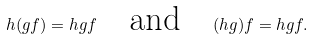<formula> <loc_0><loc_0><loc_500><loc_500>h ( g f ) = h g f \quad \text {and} \quad ( h g ) f = h g f .</formula> 